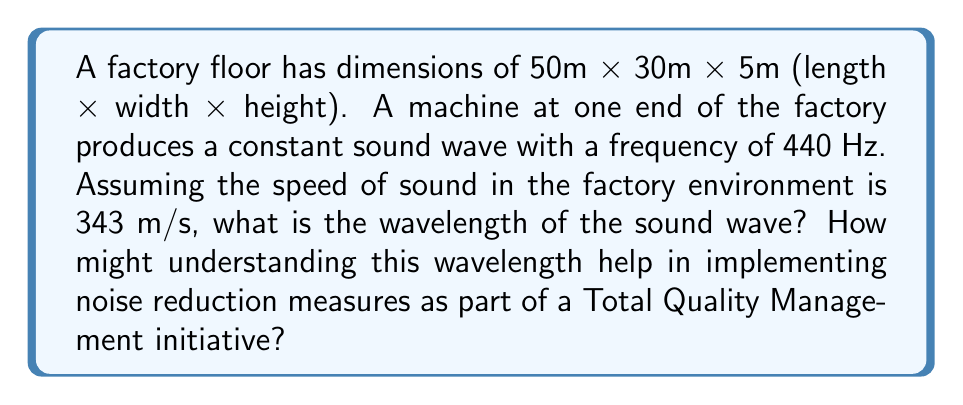Solve this math problem. To solve this problem, we'll follow these steps:

1. Recall the wave equation relating wave speed, frequency, and wavelength:
   
   $$v = f \lambda$$

   where $v$ is the wave speed, $f$ is the frequency, and $\lambda$ is the wavelength.

2. We're given:
   - Wave speed (v) = 343 m/s
   - Frequency (f) = 440 Hz

3. Rearrange the equation to solve for wavelength:

   $$\lambda = \frac{v}{f}$$

4. Substitute the known values:

   $$\lambda = \frac{343 \text{ m/s}}{440 \text{ Hz}}$$

5. Calculate:

   $$\lambda = 0.78 \text{ m}$$

Understanding this wavelength is crucial for implementing noise reduction measures:

1. Resonance: Knowing the wavelength helps identify potential resonance issues in the factory. If any dimension of the room is a multiple of half the wavelength, standing waves can form, amplifying the noise.

2. Absorption materials: The wavelength informs the thickness and type of sound-absorbing materials needed. Materials are most effective when their thickness is about 1/4 of the wavelength.

3. Barrier placement: Understanding the wavelength helps in strategically placing noise barriers or partitions to interrupt sound wave propagation.

4. Machine placement: Knowledge of wavelength can guide the optimal positioning of machines to minimize noise interference and create quieter work zones.

5. Quality control: By managing noise levels, we can improve the work environment, potentially increasing productivity and reducing errors, aligning with Total Quality Management principles.
Answer: 0.78 m 